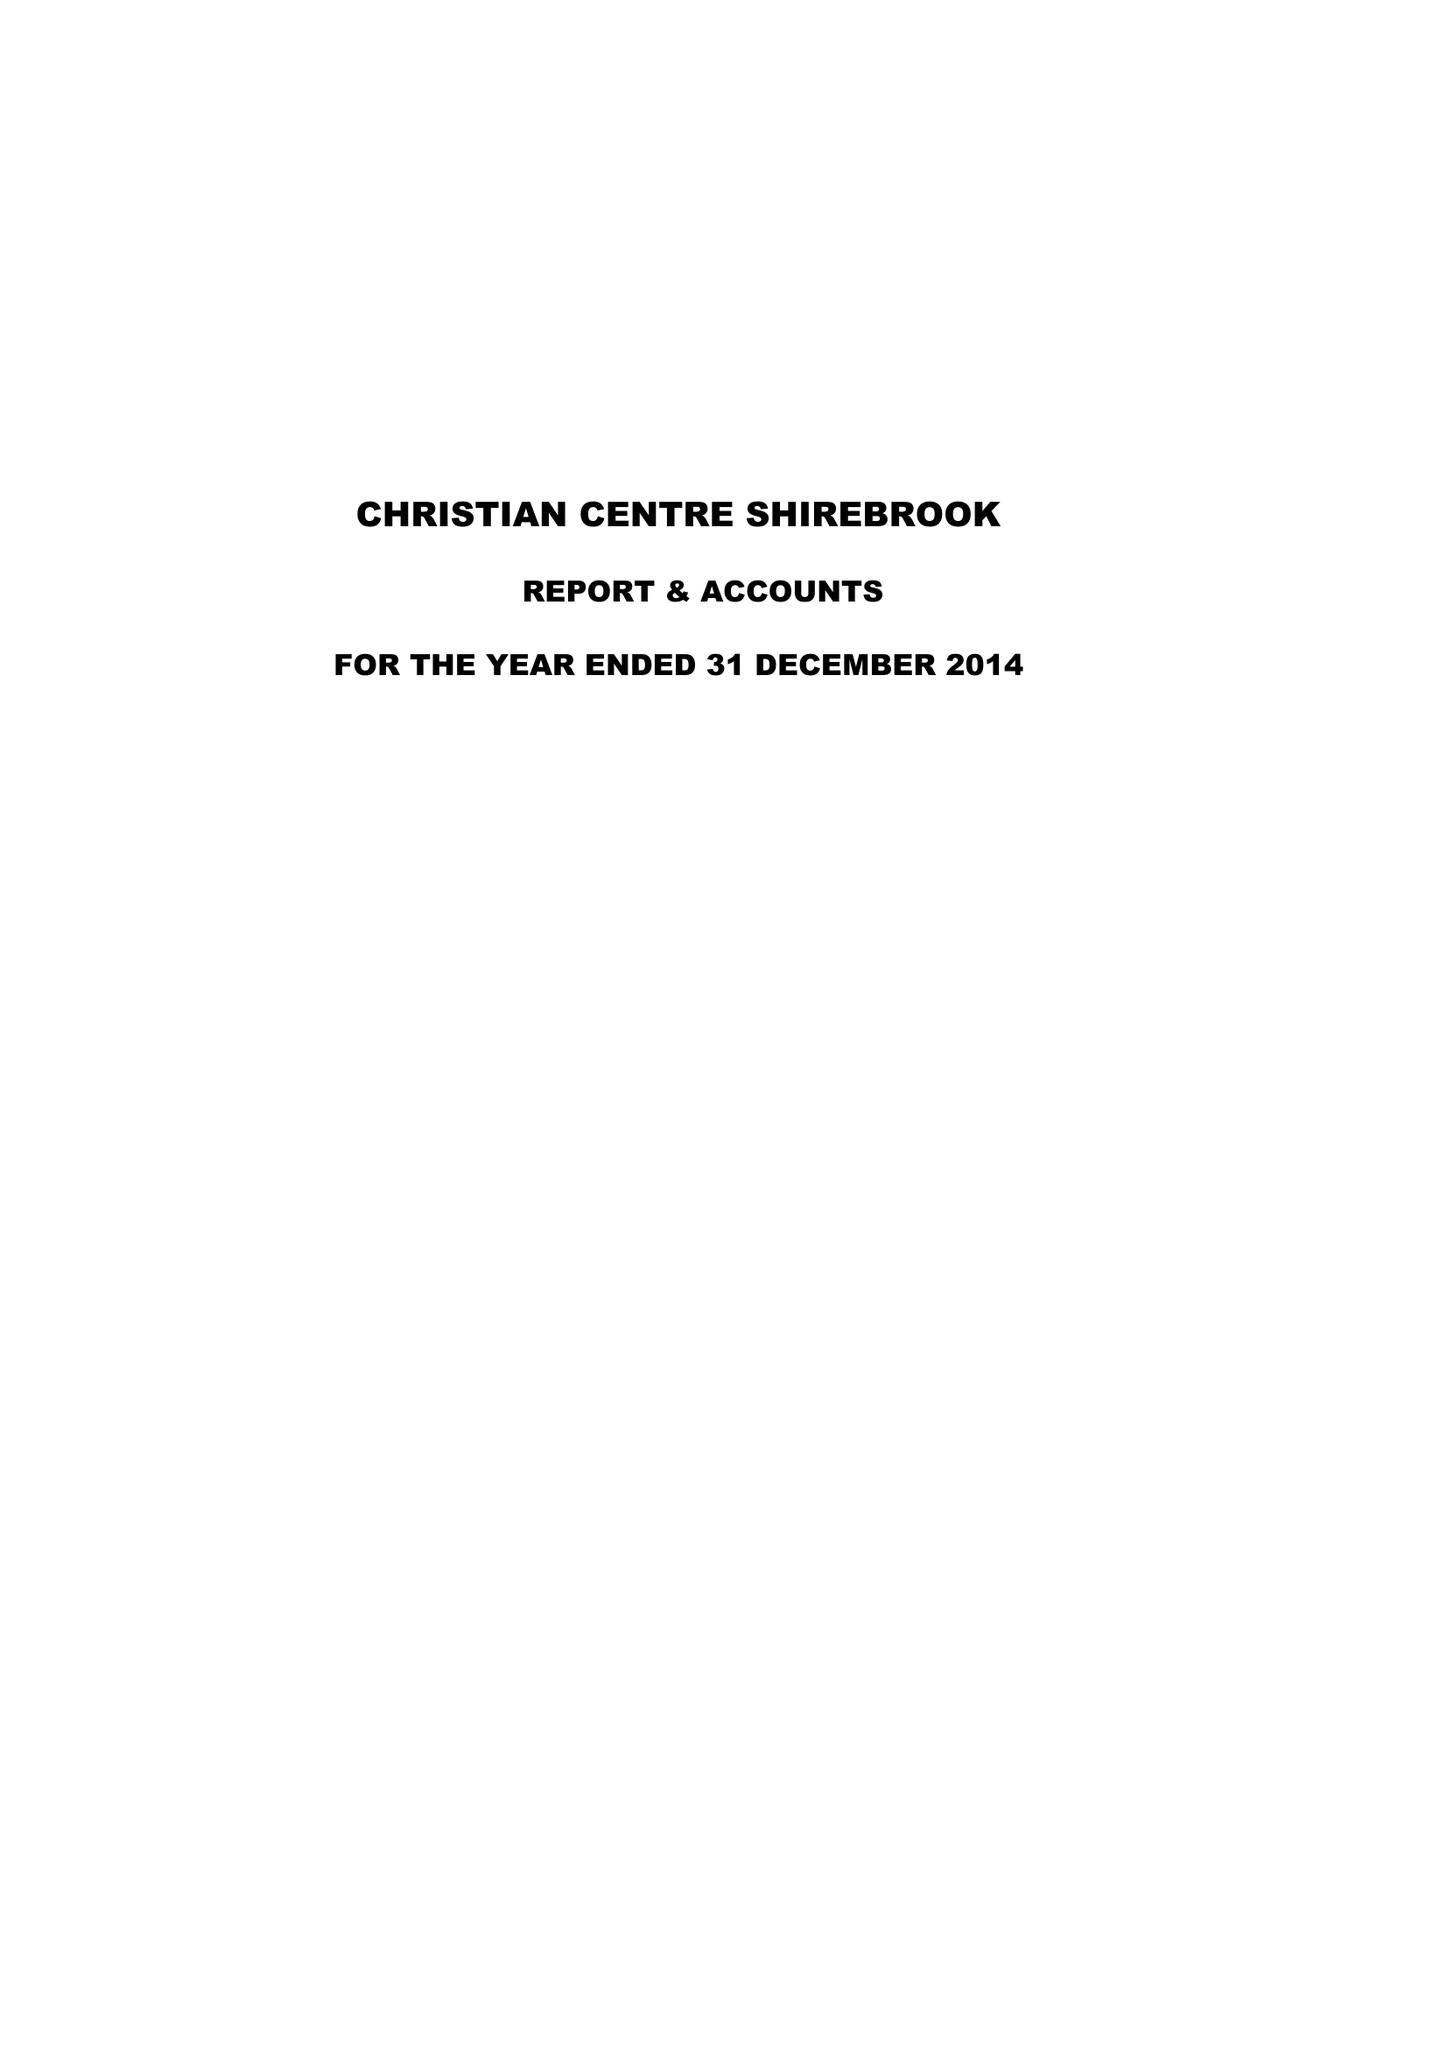What is the value for the charity_name?
Answer the question using a single word or phrase. The Brook Community Church and Centre 